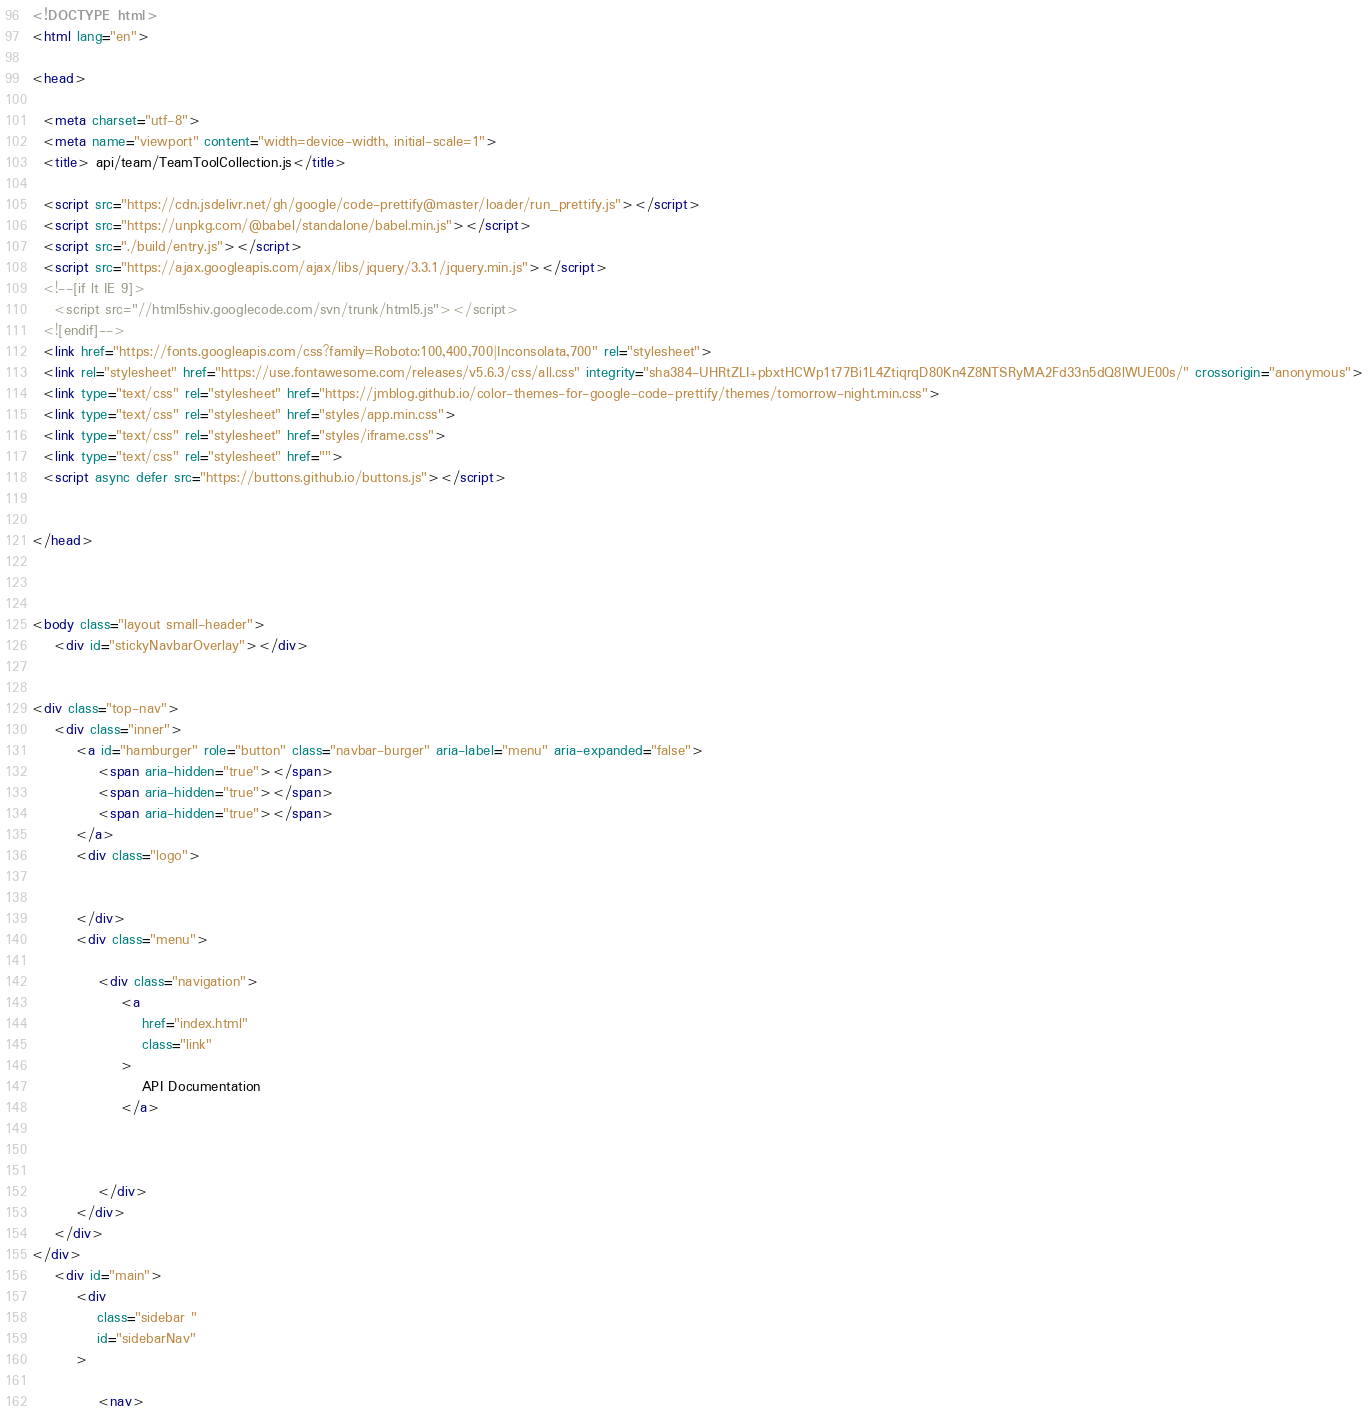Convert code to text. <code><loc_0><loc_0><loc_500><loc_500><_HTML_>

<!DOCTYPE html>
<html lang="en">

<head>

  <meta charset="utf-8">
  <meta name="viewport" content="width=device-width, initial-scale=1">
  <title> api/team/TeamToolCollection.js</title>

  <script src="https://cdn.jsdelivr.net/gh/google/code-prettify@master/loader/run_prettify.js"></script>
  <script src="https://unpkg.com/@babel/standalone/babel.min.js"></script>
  <script src="./build/entry.js"></script>
  <script src="https://ajax.googleapis.com/ajax/libs/jquery/3.3.1/jquery.min.js"></script>
  <!--[if lt IE 9]>
    <script src="//html5shiv.googlecode.com/svn/trunk/html5.js"></script>
  <![endif]-->
  <link href="https://fonts.googleapis.com/css?family=Roboto:100,400,700|Inconsolata,700" rel="stylesheet">
  <link rel="stylesheet" href="https://use.fontawesome.com/releases/v5.6.3/css/all.css" integrity="sha384-UHRtZLI+pbxtHCWp1t77Bi1L4ZtiqrqD80Kn4Z8NTSRyMA2Fd33n5dQ8lWUE00s/" crossorigin="anonymous">
  <link type="text/css" rel="stylesheet" href="https://jmblog.github.io/color-themes-for-google-code-prettify/themes/tomorrow-night.min.css">
  <link type="text/css" rel="stylesheet" href="styles/app.min.css">
  <link type="text/css" rel="stylesheet" href="styles/iframe.css">
  <link type="text/css" rel="stylesheet" href="">
  <script async defer src="https://buttons.github.io/buttons.js"></script>


</head>



<body class="layout small-header">
    <div id="stickyNavbarOverlay"></div>


<div class="top-nav">
    <div class="inner">
        <a id="hamburger" role="button" class="navbar-burger" aria-label="menu" aria-expanded="false">
            <span aria-hidden="true"></span>
            <span aria-hidden="true"></span>
            <span aria-hidden="true"></span>
        </a>
        <div class="logo">


        </div>
        <div class="menu">

            <div class="navigation">
                <a
                    href="index.html"
                    class="link"
                >
                    API Documentation
                </a>



            </div>
        </div>
    </div>
</div>
    <div id="main">
        <div
            class="sidebar "
            id="sidebarNav"
        >

            <nav>
</code> 